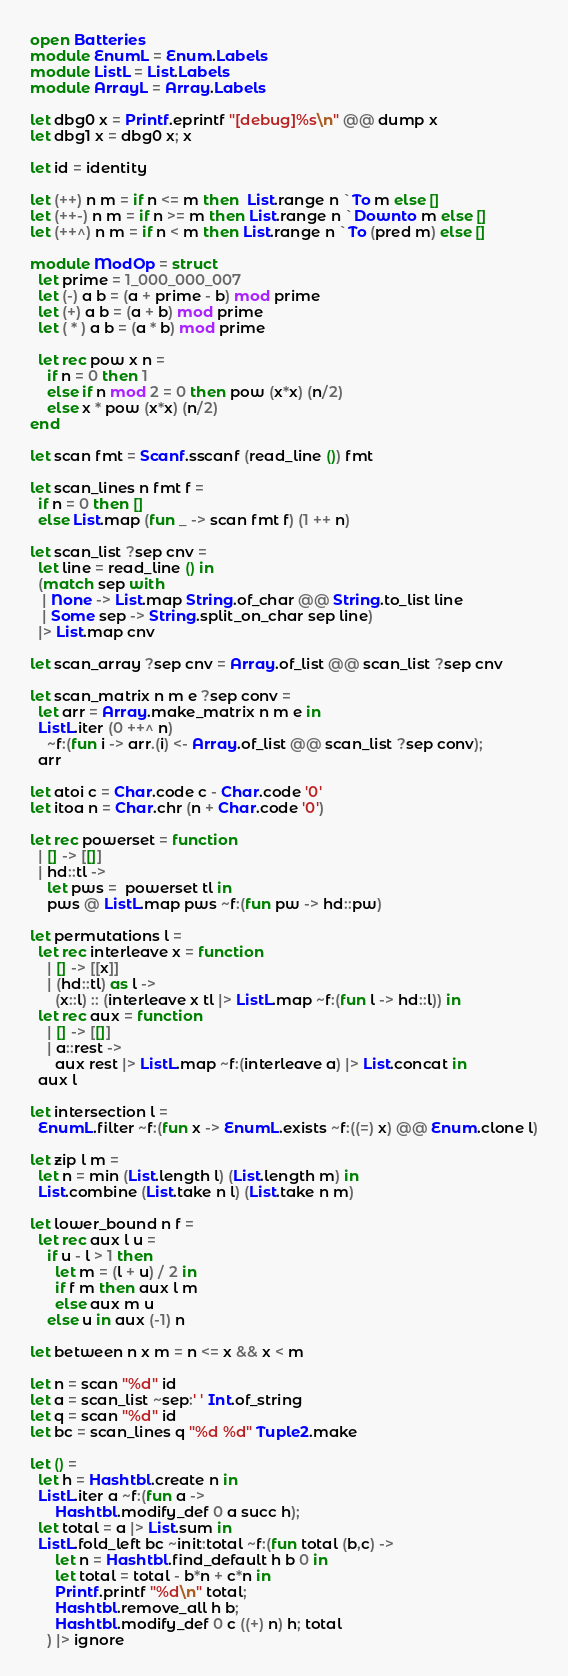<code> <loc_0><loc_0><loc_500><loc_500><_OCaml_>open Batteries
module EnumL = Enum.Labels
module ListL = List.Labels
module ArrayL = Array.Labels

let dbg0 x = Printf.eprintf "[debug]%s\n" @@ dump x
let dbg1 x = dbg0 x; x

let id = identity

let (++) n m = if n <= m then  List.range n `To m else []
let (++-) n m = if n >= m then List.range n `Downto m else []
let (++^) n m = if n < m then List.range n `To (pred m) else []

module ModOp = struct
  let prime = 1_000_000_007
  let (-) a b = (a + prime - b) mod prime
  let (+) a b = (a + b) mod prime
  let ( * ) a b = (a * b) mod prime

  let rec pow x n =
    if n = 0 then 1
    else if n mod 2 = 0 then pow (x*x) (n/2)
    else x * pow (x*x) (n/2)
end

let scan fmt = Scanf.sscanf (read_line ()) fmt

let scan_lines n fmt f =
  if n = 0 then []
  else List.map (fun _ -> scan fmt f) (1 ++ n)

let scan_list ?sep cnv =
  let line = read_line () in
  (match sep with
   | None -> List.map String.of_char @@ String.to_list line
   | Some sep -> String.split_on_char sep line)
  |> List.map cnv

let scan_array ?sep cnv = Array.of_list @@ scan_list ?sep cnv

let scan_matrix n m e ?sep conv =
  let arr = Array.make_matrix n m e in
  ListL.iter (0 ++^ n)
    ~f:(fun i -> arr.(i) <- Array.of_list @@ scan_list ?sep conv);
  arr

let atoi c = Char.code c - Char.code '0'
let itoa n = Char.chr (n + Char.code '0')

let rec powerset = function
  | [] -> [[]]
  | hd::tl ->
    let pws =  powerset tl in
    pws @ ListL.map pws ~f:(fun pw -> hd::pw)

let permutations l =
  let rec interleave x = function
    | [] -> [[x]]
    | (hd::tl) as l ->
      (x::l) :: (interleave x tl |> ListL.map ~f:(fun l -> hd::l)) in
  let rec aux = function
    | [] -> [[]]
    | a::rest ->
      aux rest |> ListL.map ~f:(interleave a) |> List.concat in
  aux l

let intersection l =
  EnumL.filter ~f:(fun x -> EnumL.exists ~f:((=) x) @@ Enum.clone l)

let zip l m =
  let n = min (List.length l) (List.length m) in
  List.combine (List.take n l) (List.take n m)

let lower_bound n f =
  let rec aux l u =
    if u - l > 1 then
      let m = (l + u) / 2 in
      if f m then aux l m
      else aux m u
    else u in aux (-1) n

let between n x m = n <= x && x < m

let n = scan "%d" id
let a = scan_list ~sep:' ' Int.of_string
let q = scan "%d" id
let bc = scan_lines q "%d %d" Tuple2.make

let () =
  let h = Hashtbl.create n in
  ListL.iter a ~f:(fun a ->
      Hashtbl.modify_def 0 a succ h);
  let total = a |> List.sum in
  ListL.fold_left bc ~init:total ~f:(fun total (b,c) ->
      let n = Hashtbl.find_default h b 0 in
      let total = total - b*n + c*n in
      Printf.printf "%d\n" total;
      Hashtbl.remove_all h b;
      Hashtbl.modify_def 0 c ((+) n) h; total
    ) |> ignore
</code> 